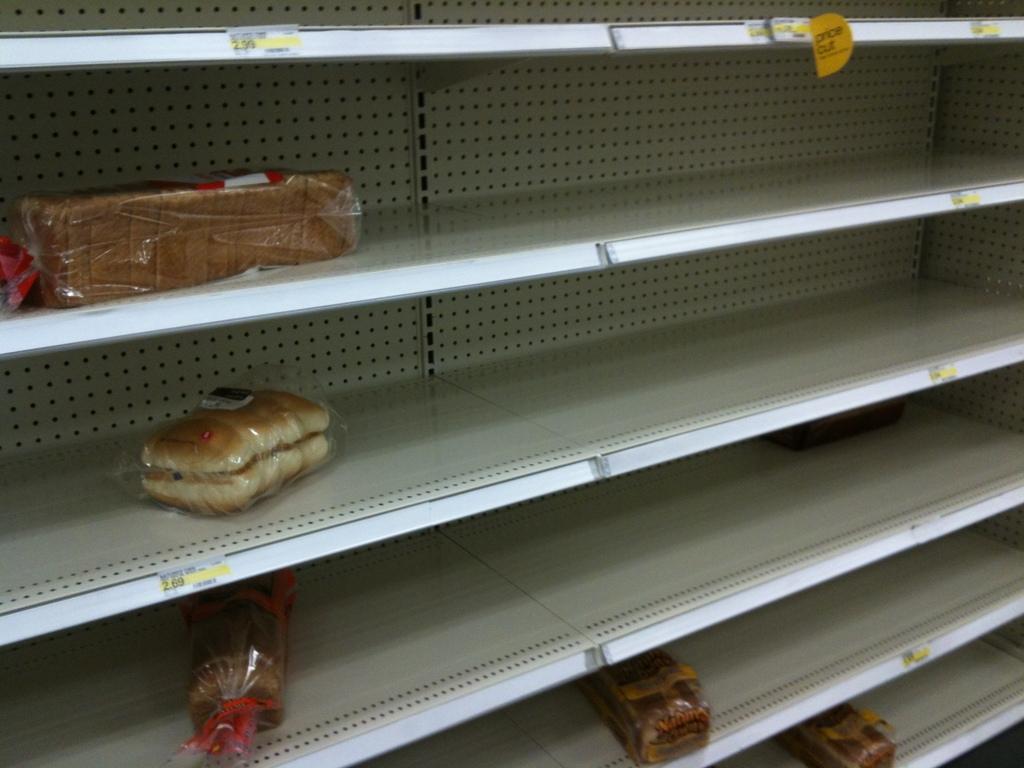In one or two sentences, can you explain what this image depicts? In this image there is one cupboard, in that cupboard there are some breads and buns. 